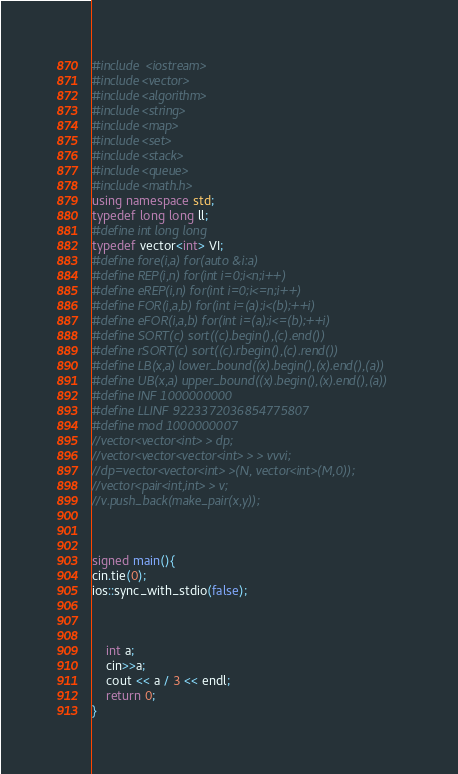<code> <loc_0><loc_0><loc_500><loc_500><_C++_>#include <iostream>
#include<vector>
#include<algorithm>
#include<string>
#include<map>
#include<set>
#include<stack>
#include<queue>
#include<math.h>
using namespace std;
typedef long long ll;
#define int long long
typedef vector<int> VI;
#define fore(i,a) for(auto &i:a)
#define REP(i,n) for(int i=0;i<n;i++)
#define eREP(i,n) for(int i=0;i<=n;i++)
#define FOR(i,a,b) for(int i=(a);i<(b);++i)
#define eFOR(i,a,b) for(int i=(a);i<=(b);++i)
#define SORT(c) sort((c).begin(),(c).end())
#define rSORT(c) sort((c).rbegin(),(c).rend())
#define LB(x,a) lower_bound((x).begin(),(x).end(),(a))
#define UB(x,a) upper_bound((x).begin(),(x).end(),(a))
#define INF 1000000000
#define LLINF 9223372036854775807
#define mod 1000000007
//vector<vector<int> > dp;
//vector<vector<vector<int> > > vvvi;
//dp=vector<vector<int> >(N, vector<int>(M,0));
//vector<pair<int,int> > v;
//v.push_back(make_pair(x,y));



signed main(){
cin.tie(0);
ios::sync_with_stdio(false);



	int a;
	cin>>a;
	cout << a / 3 << endl;
	return 0;
}

</code> 